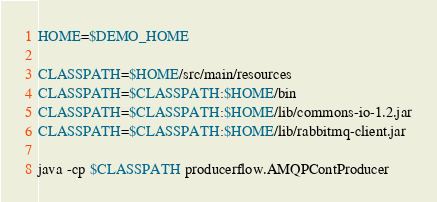<code> <loc_0><loc_0><loc_500><loc_500><_Bash_>HOME=$DEMO_HOME

CLASSPATH=$HOME/src/main/resources
CLASSPATH=$CLASSPATH:$HOME/bin
CLASSPATH=$CLASSPATH:$HOME/lib/commons-io-1.2.jar
CLASSPATH=$CLASSPATH:$HOME/lib/rabbitmq-client.jar

java -cp $CLASSPATH producerflow.AMQPContProducer
</code> 